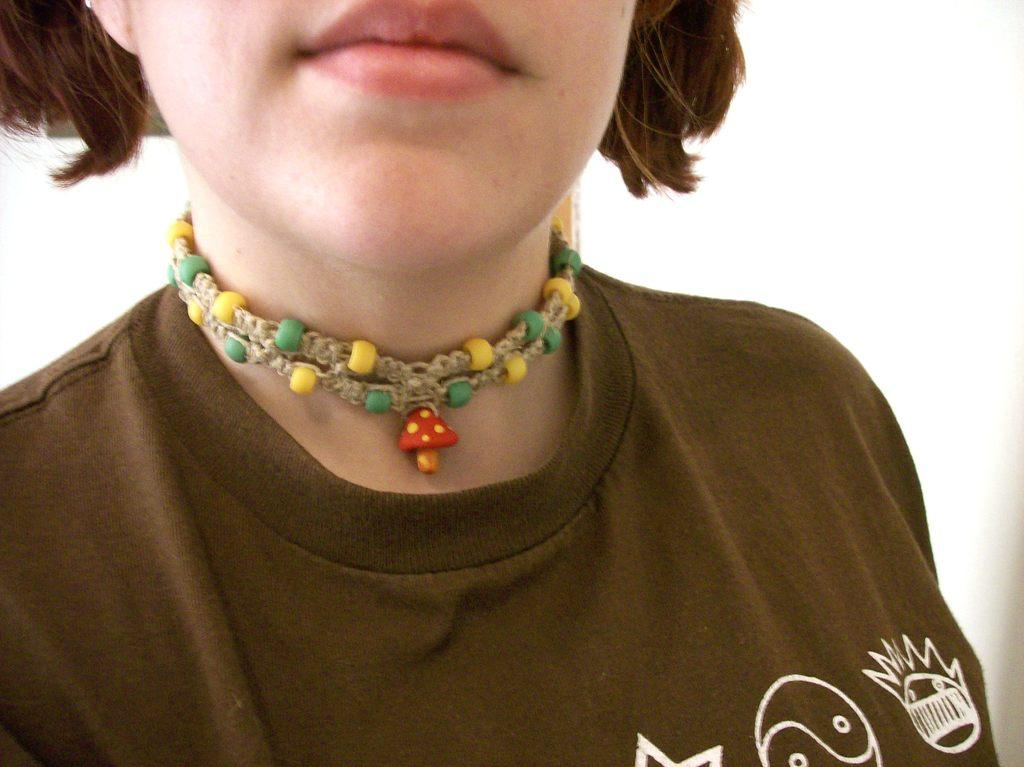What is the main subject of the image? There is a person in the image. Can you describe the background of the image? There is a wall visible behind the person. What type of trail can be seen behind the person in the image? There is no trail visible behind the person in the image. What is the person holding in their hand in the image? The provided facts do not mention anything about the person holding an object in their hand. 